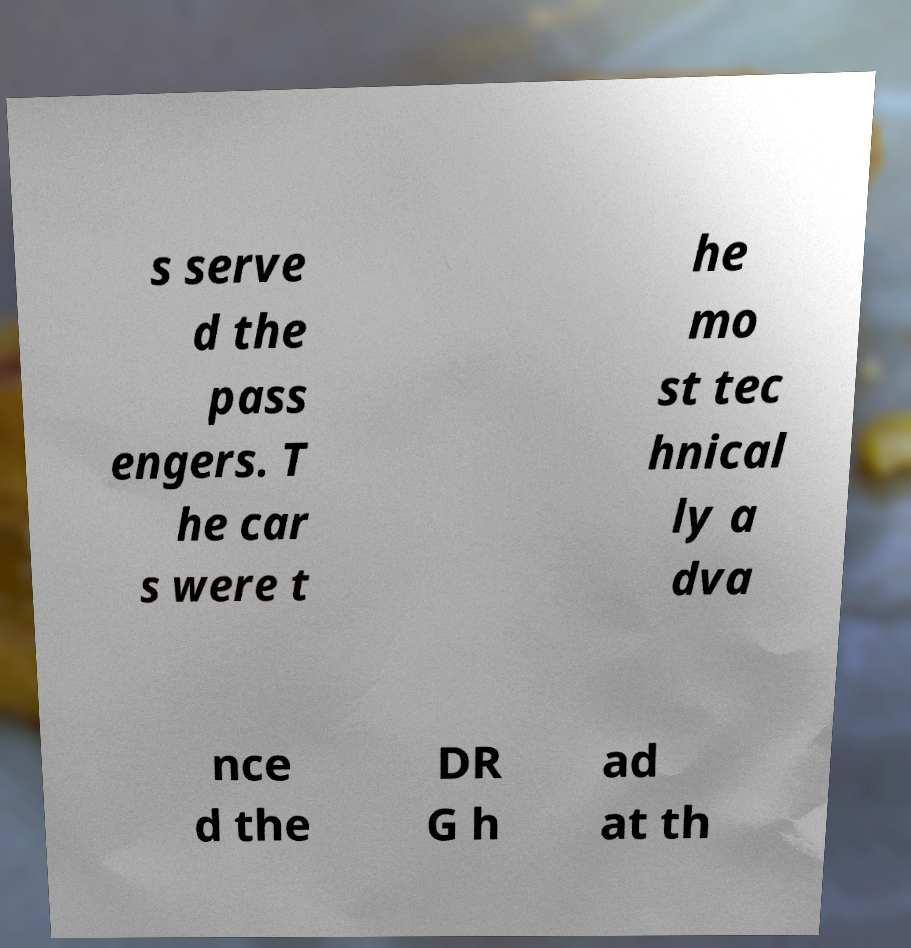I need the written content from this picture converted into text. Can you do that? s serve d the pass engers. T he car s were t he mo st tec hnical ly a dva nce d the DR G h ad at th 